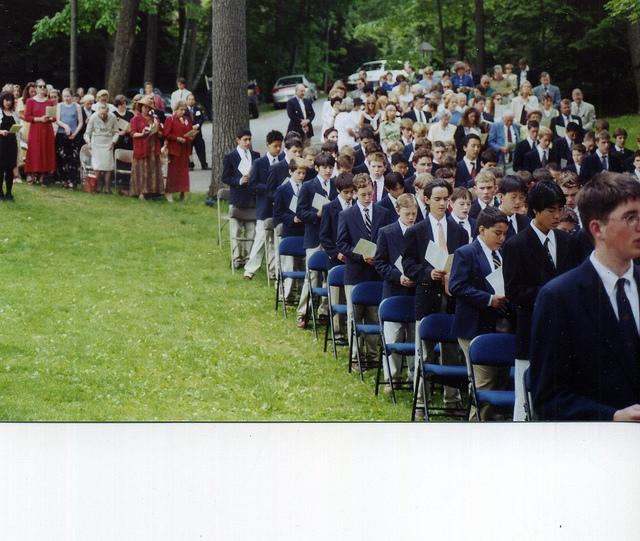Are all the boys wearing the same color blazer?
Concise answer only. Yes. How many people are in the image?
Keep it brief. Many. Where do most of the people have one of their arms?
Quick response, please. Laps. What color are the chairs?
Concise answer only. Blue. Is this a wedding?
Keep it brief. No. 